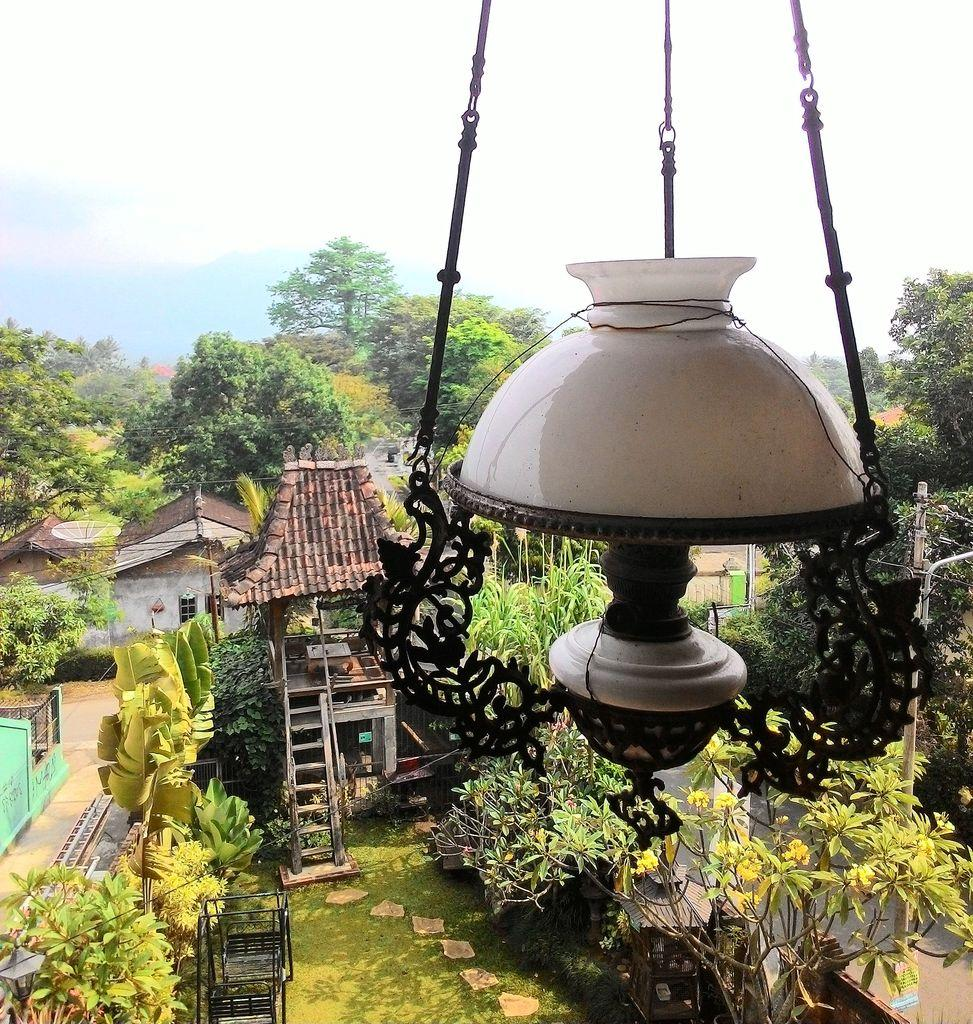What type of structure is present in the image? There is a building in the image. What is the color of the building? The building is white. What other natural elements can be seen in the image? There are trees in the image. What is the color of the trees? The trees are green. What type of lighting fixture is visible in the image? There is a light hanging in the image. What can be seen in the background of the image? The sky is visible in the background of the image. What colors are present in the sky? The sky is white and blue. How many cats are wearing sweaters in the image? There are no cats or sweaters present in the image. What type of story is being told in the image? The image does not depict a story; it is a visual representation of a building, trees, a light, and the sky. 